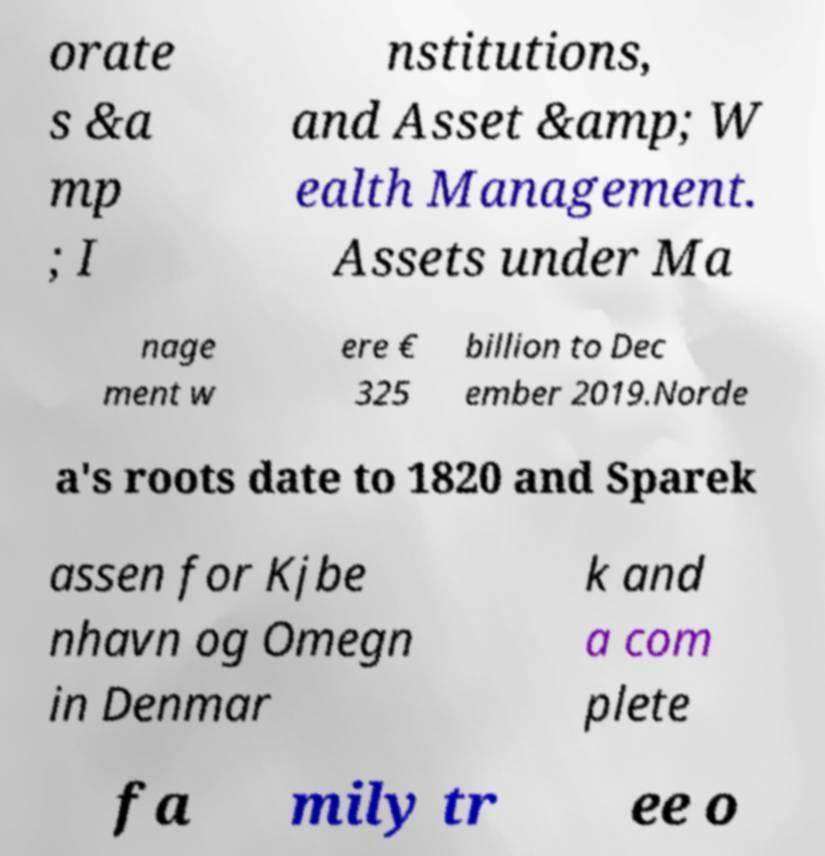Can you read and provide the text displayed in the image?This photo seems to have some interesting text. Can you extract and type it out for me? orate s &a mp ; I nstitutions, and Asset &amp; W ealth Management. Assets under Ma nage ment w ere € 325 billion to Dec ember 2019.Norde a's roots date to 1820 and Sparek assen for Kjbe nhavn og Omegn in Denmar k and a com plete fa mily tr ee o 